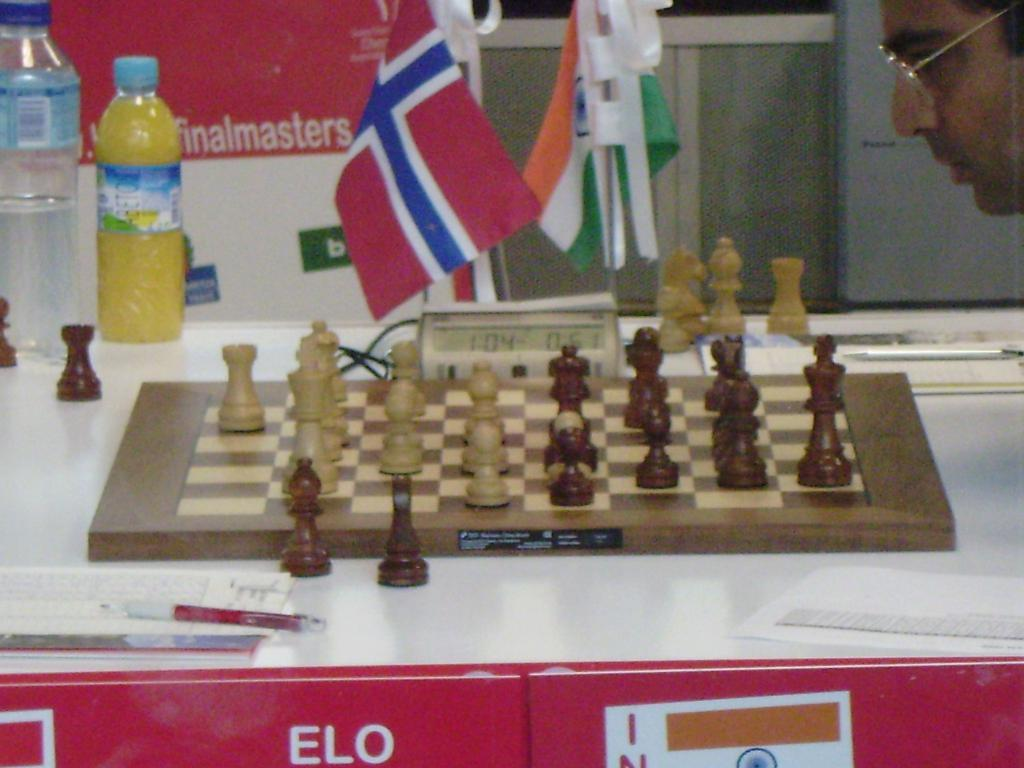Provide a one-sentence caption for the provided image. A man is thinking really hard in a Finalmasters chess game. 